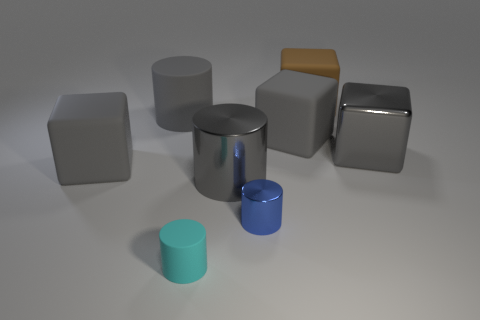Subtract all gray shiny cubes. How many cubes are left? 3 Add 1 tiny cyan rubber cylinders. How many objects exist? 9 Subtract all cyan blocks. How many gray cylinders are left? 2 Subtract all cyan cylinders. How many cylinders are left? 3 Subtract 1 blocks. How many blocks are left? 3 Add 7 tiny shiny cylinders. How many tiny shiny cylinders exist? 8 Subtract 0 brown cylinders. How many objects are left? 8 Subtract all yellow blocks. Subtract all gray cylinders. How many blocks are left? 4 Subtract all tiny cyan cylinders. Subtract all big gray metallic cylinders. How many objects are left? 6 Add 4 blue shiny cylinders. How many blue shiny cylinders are left? 5 